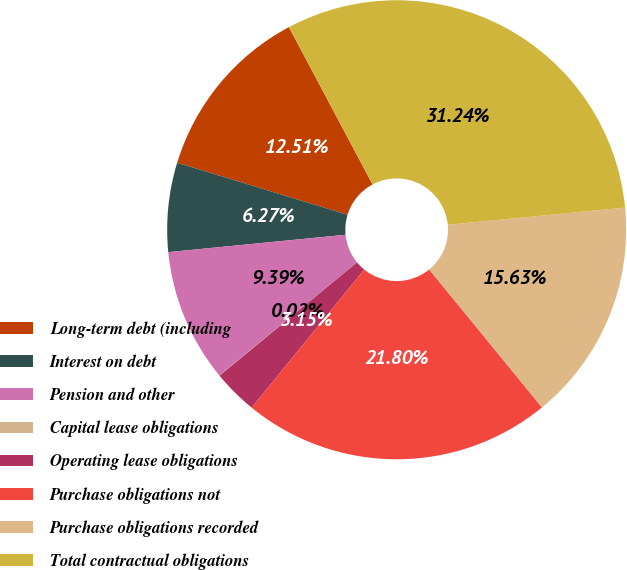Convert chart. <chart><loc_0><loc_0><loc_500><loc_500><pie_chart><fcel>Long-term debt (including<fcel>Interest on debt<fcel>Pension and other<fcel>Capital lease obligations<fcel>Operating lease obligations<fcel>Purchase obligations not<fcel>Purchase obligations recorded<fcel>Total contractual obligations<nl><fcel>12.51%<fcel>6.27%<fcel>9.39%<fcel>0.02%<fcel>3.15%<fcel>21.8%<fcel>15.63%<fcel>31.24%<nl></chart> 